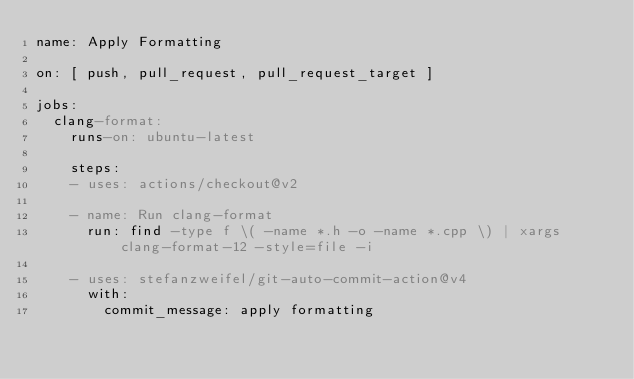Convert code to text. <code><loc_0><loc_0><loc_500><loc_500><_YAML_>name: Apply Formatting

on: [ push, pull_request, pull_request_target ]

jobs:
  clang-format:
    runs-on: ubuntu-latest

    steps:
    - uses: actions/checkout@v2
        
    - name: Run clang-format
      run: find -type f \( -name *.h -o -name *.cpp \) | xargs clang-format-12 -style=file -i

    - uses: stefanzweifel/git-auto-commit-action@v4
      with:
        commit_message: apply formatting
</code> 